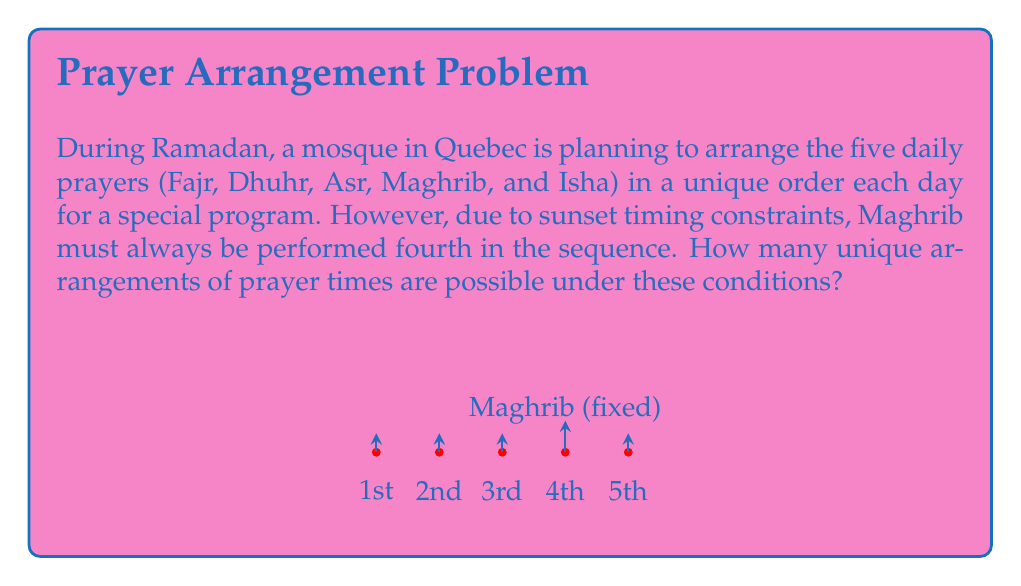What is the answer to this math problem? Let's approach this step-by-step using permutation groups:

1) We have 5 prayers in total, but Maghrib is fixed in the 4th position. This means we only need to arrange the other 4 prayers.

2) We can think of this as filling 4 slots (1st, 2nd, 3rd, and 5th positions) with 4 different prayers (Fajr, Dhuhr, Asr, and Isha).

3) This is a classic permutation problem. The number of ways to arrange n distinct objects is given by n!

4) In this case, n = 4, so we have 4! possible arrangements.

5) Let's calculate 4!:
   $$4! = 4 \times 3 \times 2 \times 1 = 24$$

6) We can also think about this in terms of group theory:
   - The symmetric group $S_5$ represents all permutations of 5 elements.
   - Our constraint (Maghrib fixed) creates a subgroup isomorphic to $S_4$.
   - The order of this subgroup is |$S_4$| = 4! = 24

Therefore, there are 24 unique arrangements possible under these conditions.
Answer: 24 